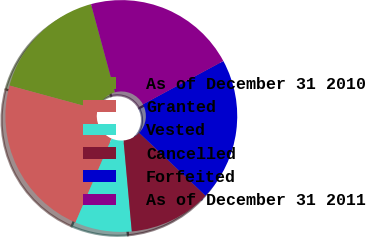Convert chart to OTSL. <chart><loc_0><loc_0><loc_500><loc_500><pie_chart><fcel>As of December 31 2010<fcel>Granted<fcel>Vested<fcel>Cancelled<fcel>Forfeited<fcel>As of December 31 2011<nl><fcel>16.56%<fcel>22.75%<fcel>7.91%<fcel>11.5%<fcel>19.92%<fcel>21.34%<nl></chart> 